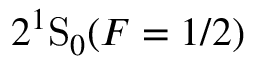<formula> <loc_0><loc_0><loc_500><loc_500>2 ^ { 1 } S _ { 0 } ( F = 1 / 2 )</formula> 